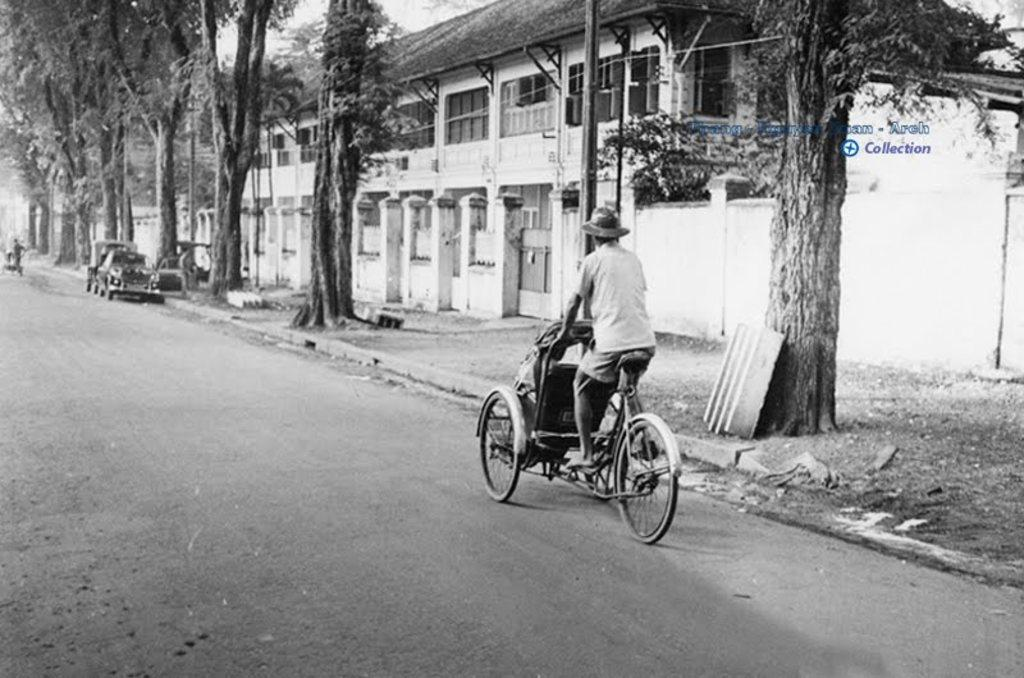What is the person in the image riding? The person is riding a tricycle in the image. Where is the tricycle located? The tricycle is on the road. What can be seen in the background of the image? There are buildings, cars, and trees in the background of the image. Where is the sheet being used in the image? There is no sheet present in the image. What type of garden can be seen in the image? There is no garden present in the image. 